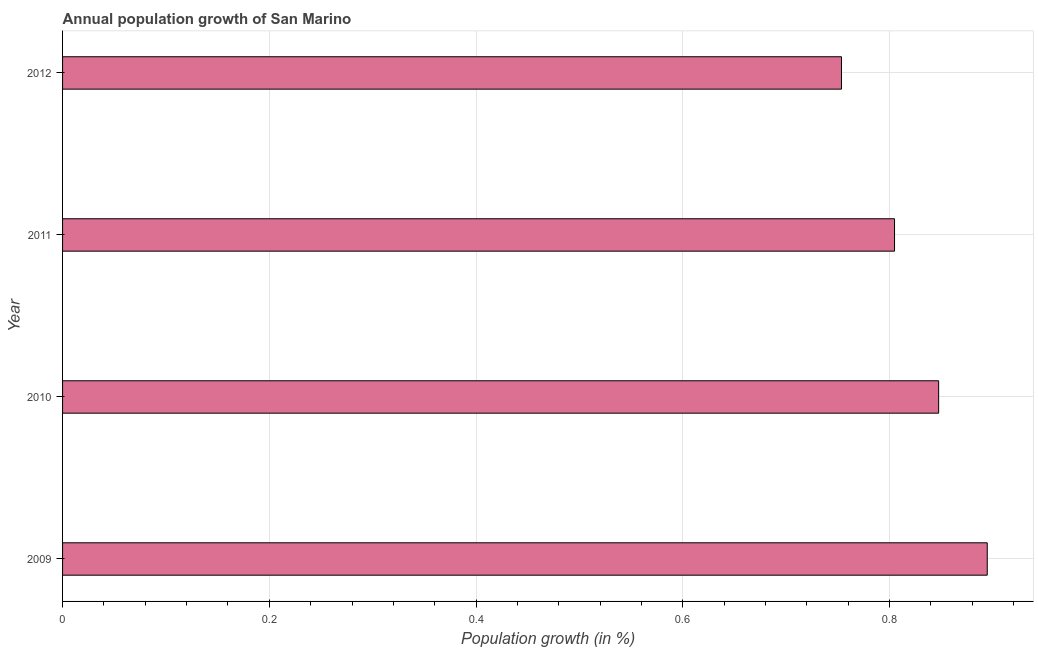Does the graph contain grids?
Offer a very short reply. Yes. What is the title of the graph?
Your answer should be very brief. Annual population growth of San Marino. What is the label or title of the X-axis?
Provide a short and direct response. Population growth (in %). What is the population growth in 2009?
Make the answer very short. 0.89. Across all years, what is the maximum population growth?
Keep it short and to the point. 0.89. Across all years, what is the minimum population growth?
Your answer should be very brief. 0.75. What is the sum of the population growth?
Make the answer very short. 3.3. What is the difference between the population growth in 2010 and 2012?
Provide a succinct answer. 0.09. What is the average population growth per year?
Give a very brief answer. 0.82. What is the median population growth?
Your answer should be compact. 0.83. Do a majority of the years between 2011 and 2010 (inclusive) have population growth greater than 0.4 %?
Your answer should be compact. No. What is the ratio of the population growth in 2010 to that in 2011?
Provide a short and direct response. 1.05. What is the difference between the highest and the second highest population growth?
Offer a very short reply. 0.05. Is the sum of the population growth in 2011 and 2012 greater than the maximum population growth across all years?
Provide a succinct answer. Yes. What is the difference between the highest and the lowest population growth?
Your response must be concise. 0.14. How many bars are there?
Give a very brief answer. 4. How many years are there in the graph?
Provide a short and direct response. 4. What is the difference between two consecutive major ticks on the X-axis?
Your response must be concise. 0.2. What is the Population growth (in %) in 2009?
Provide a short and direct response. 0.89. What is the Population growth (in %) of 2010?
Your answer should be very brief. 0.85. What is the Population growth (in %) of 2011?
Offer a very short reply. 0.8. What is the Population growth (in %) of 2012?
Your answer should be very brief. 0.75. What is the difference between the Population growth (in %) in 2009 and 2010?
Offer a terse response. 0.05. What is the difference between the Population growth (in %) in 2009 and 2011?
Offer a terse response. 0.09. What is the difference between the Population growth (in %) in 2009 and 2012?
Offer a very short reply. 0.14. What is the difference between the Population growth (in %) in 2010 and 2011?
Keep it short and to the point. 0.04. What is the difference between the Population growth (in %) in 2010 and 2012?
Your response must be concise. 0.09. What is the difference between the Population growth (in %) in 2011 and 2012?
Keep it short and to the point. 0.05. What is the ratio of the Population growth (in %) in 2009 to that in 2010?
Your response must be concise. 1.05. What is the ratio of the Population growth (in %) in 2009 to that in 2011?
Your answer should be very brief. 1.11. What is the ratio of the Population growth (in %) in 2009 to that in 2012?
Keep it short and to the point. 1.19. What is the ratio of the Population growth (in %) in 2010 to that in 2011?
Offer a terse response. 1.05. What is the ratio of the Population growth (in %) in 2011 to that in 2012?
Provide a succinct answer. 1.07. 